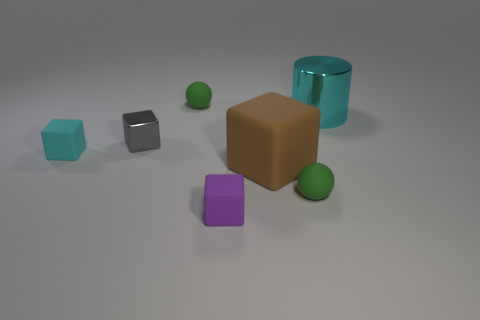Are there any other things that have the same shape as the big brown thing?
Your answer should be very brief. Yes. There is a brown matte thing; is its shape the same as the green rubber thing behind the small cyan rubber object?
Your answer should be compact. No. The brown matte object that is the same shape as the small purple matte thing is what size?
Ensure brevity in your answer.  Large. What number of other things are there of the same material as the tiny cyan object
Your response must be concise. 4. What is the large cyan object made of?
Your answer should be very brief. Metal. Is the color of the small thing behind the metallic block the same as the large object in front of the big cyan cylinder?
Provide a succinct answer. No. Are there more cyan metallic cylinders to the right of the big cyan cylinder than tiny green matte balls?
Your answer should be compact. No. What number of other things are the same color as the tiny metallic object?
Ensure brevity in your answer.  0. There is a green matte sphere that is left of the purple thing; does it have the same size as the tiny purple rubber object?
Offer a terse response. Yes. Are there any cyan objects of the same size as the purple cube?
Your answer should be very brief. Yes. 